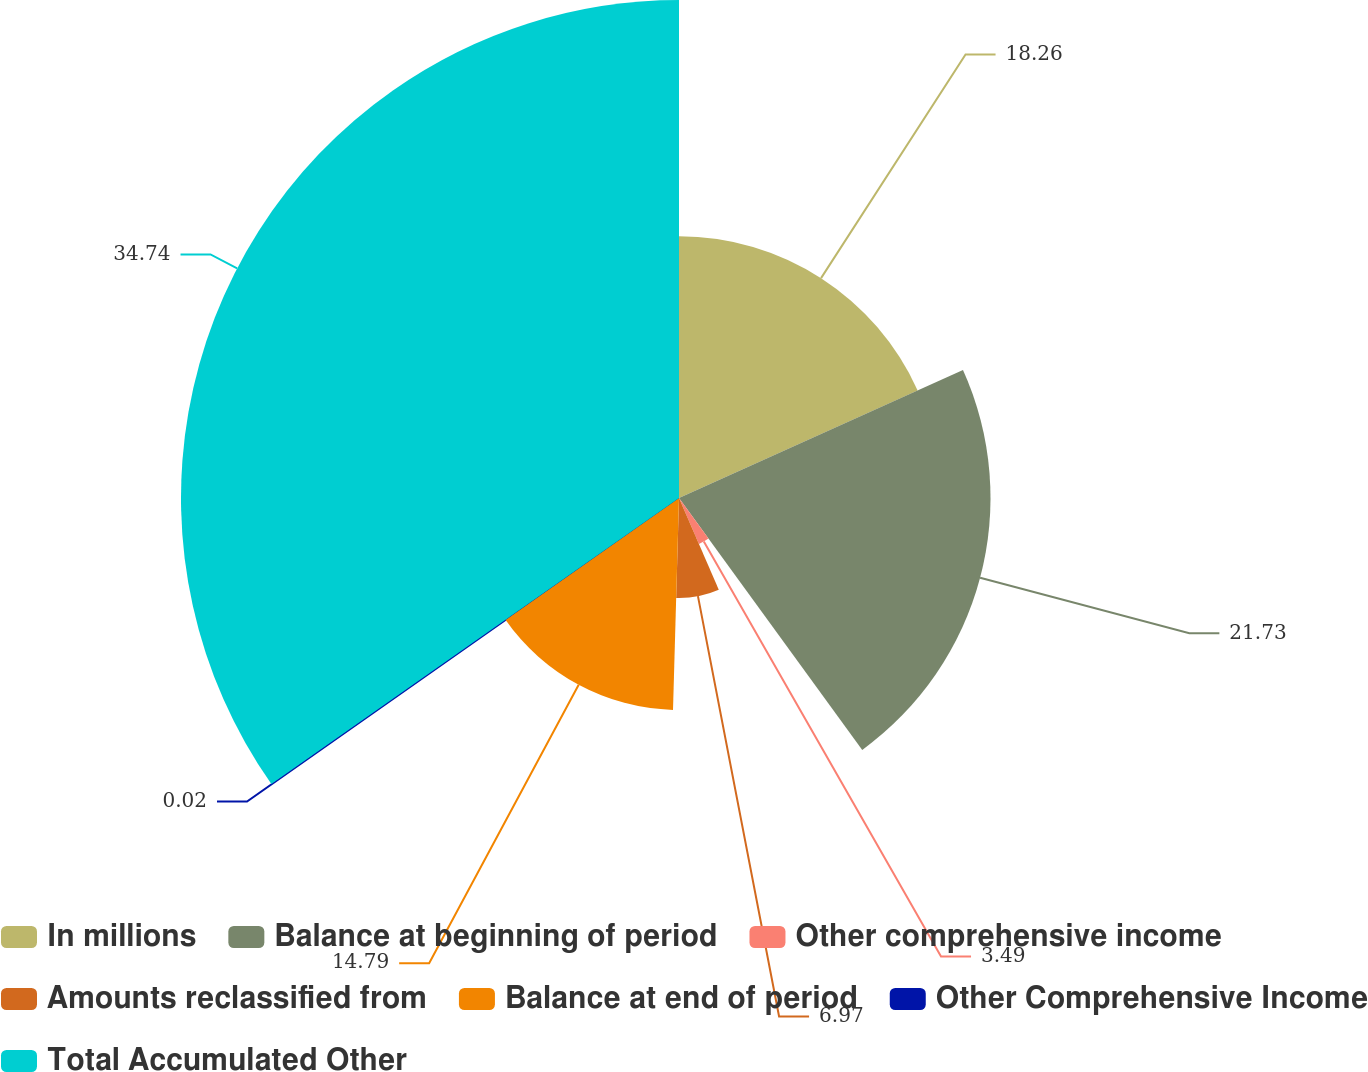<chart> <loc_0><loc_0><loc_500><loc_500><pie_chart><fcel>In millions<fcel>Balance at beginning of period<fcel>Other comprehensive income<fcel>Amounts reclassified from<fcel>Balance at end of period<fcel>Other Comprehensive Income<fcel>Total Accumulated Other<nl><fcel>18.26%<fcel>21.73%<fcel>3.49%<fcel>6.97%<fcel>14.79%<fcel>0.02%<fcel>34.74%<nl></chart> 